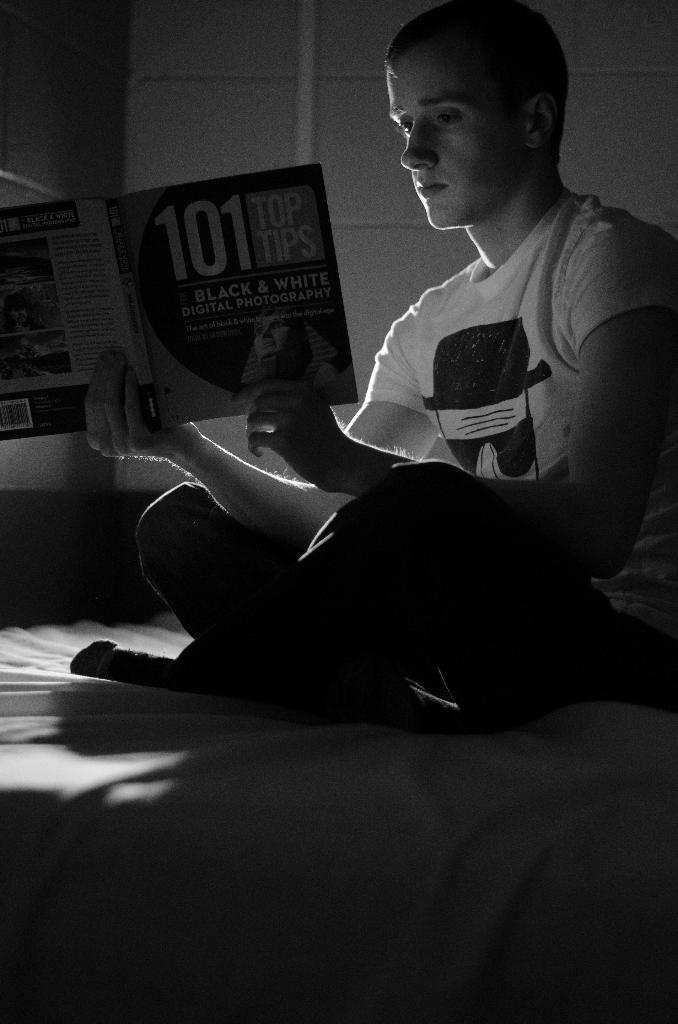In one or two sentences, can you explain what this image depicts? In the center we can see one person is sitting on the bed and he is reading book. 